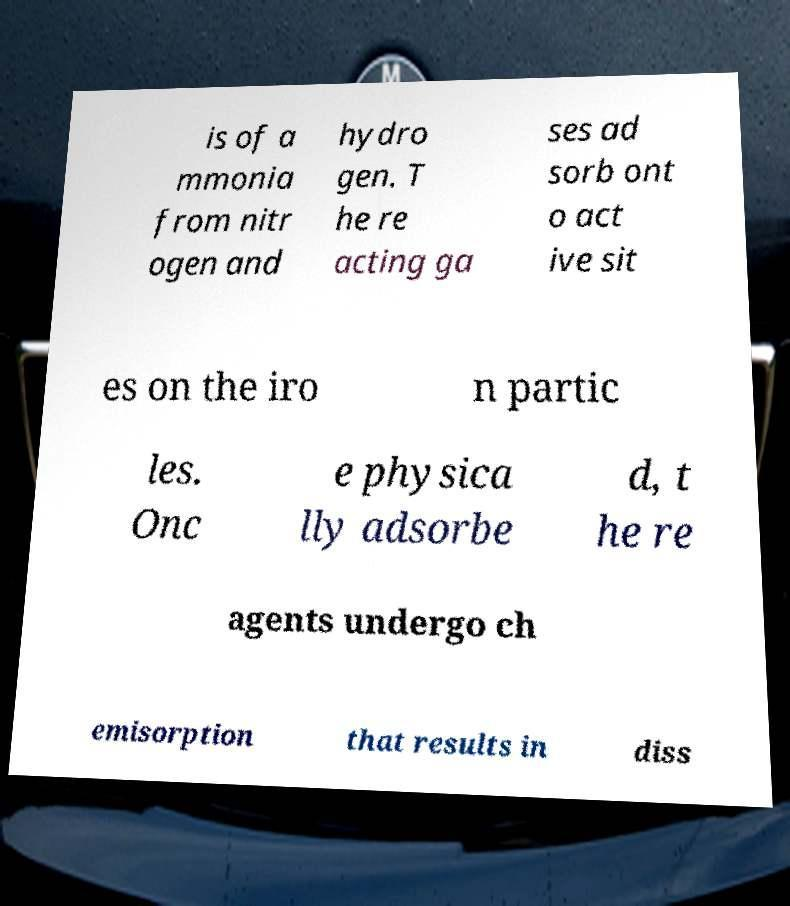Can you read and provide the text displayed in the image?This photo seems to have some interesting text. Can you extract and type it out for me? is of a mmonia from nitr ogen and hydro gen. T he re acting ga ses ad sorb ont o act ive sit es on the iro n partic les. Onc e physica lly adsorbe d, t he re agents undergo ch emisorption that results in diss 